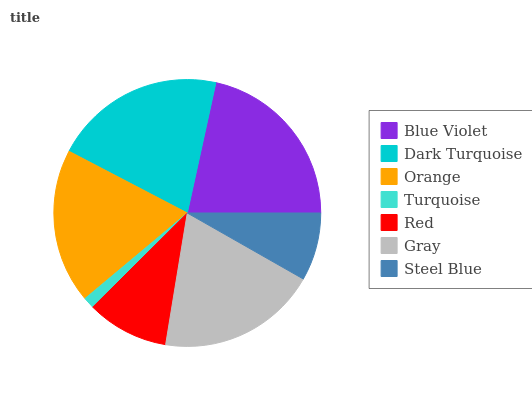Is Turquoise the minimum?
Answer yes or no. Yes. Is Blue Violet the maximum?
Answer yes or no. Yes. Is Dark Turquoise the minimum?
Answer yes or no. No. Is Dark Turquoise the maximum?
Answer yes or no. No. Is Blue Violet greater than Dark Turquoise?
Answer yes or no. Yes. Is Dark Turquoise less than Blue Violet?
Answer yes or no. Yes. Is Dark Turquoise greater than Blue Violet?
Answer yes or no. No. Is Blue Violet less than Dark Turquoise?
Answer yes or no. No. Is Orange the high median?
Answer yes or no. Yes. Is Orange the low median?
Answer yes or no. Yes. Is Dark Turquoise the high median?
Answer yes or no. No. Is Dark Turquoise the low median?
Answer yes or no. No. 